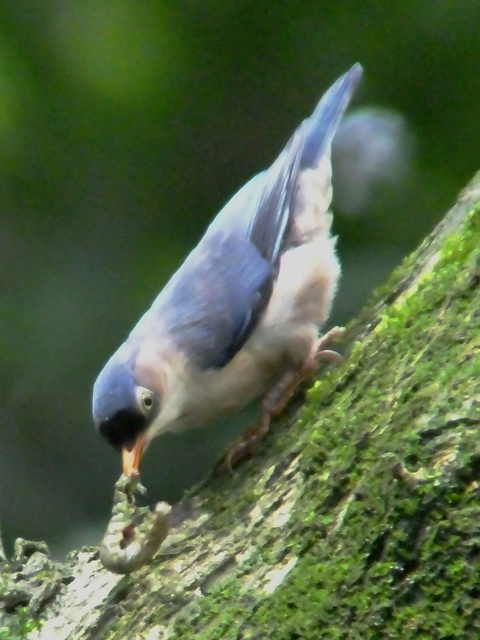Describe the objects in this image and their specific colors. I can see a bird in darkgreen, gray, darkgray, lightgray, and black tones in this image. 